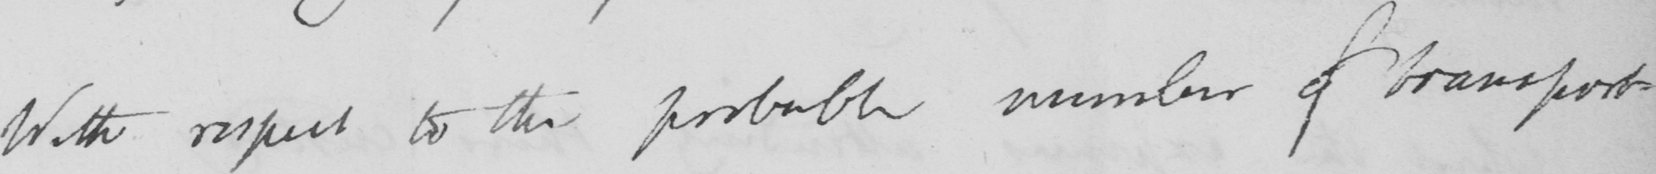Transcribe the text shown in this historical manuscript line. With respect to the probably number of transport- 